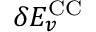Convert formula to latex. <formula><loc_0><loc_0><loc_500><loc_500>\delta E _ { v } ^ { C C }</formula> 